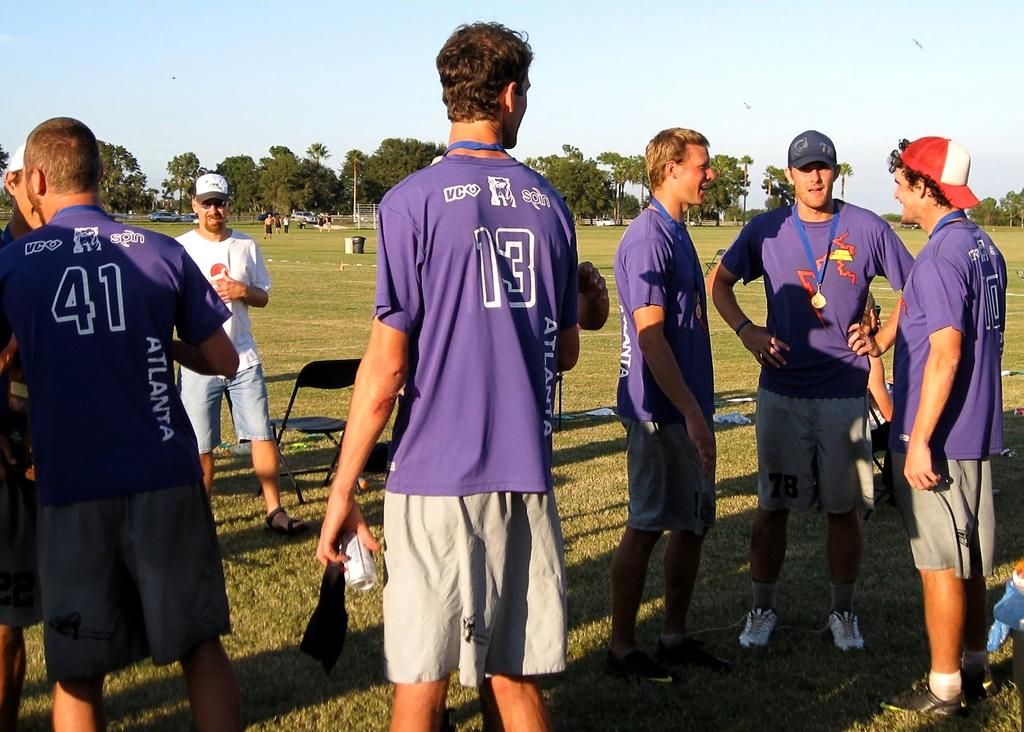Provide a one-sentence caption for the provided image. Several young men stand around conversating all wearing the same shirts one with the number forty one embroidered on his shirt. 